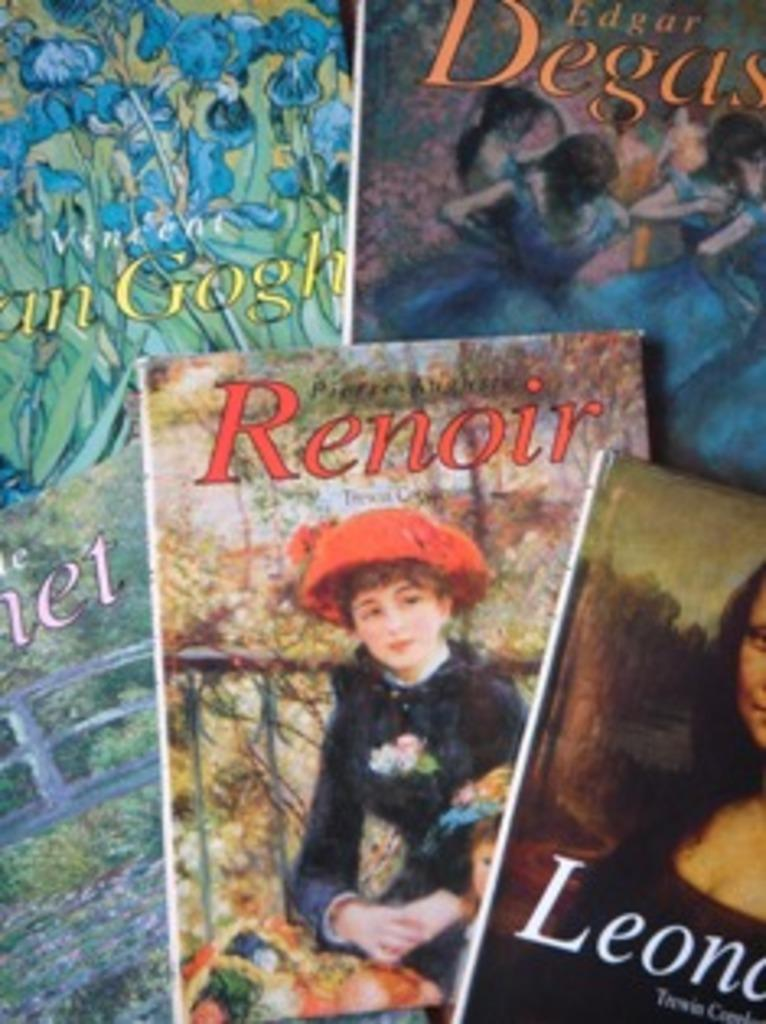<image>
Relay a brief, clear account of the picture shown. A book about artists, including Renoir, are stacked up on top of each other. 